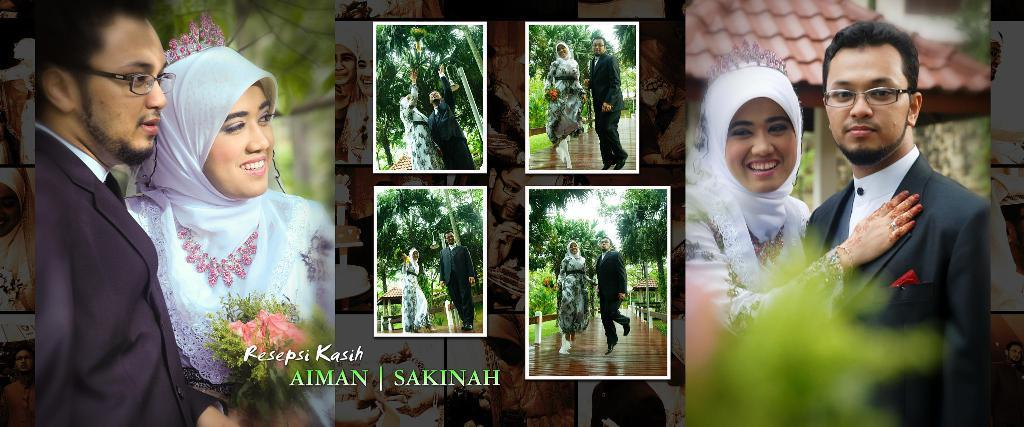Who are the people in the image? There is a man and a woman in the image. What are the genders of the individuals in the image? The man is male, and the woman is female. Can you describe the relationship between the man and the woman in the image? The facts provided do not give any information about the relationship between the man and the woman. What color is the wren perched on the man's shoulder in the image? There is no wren present in the image. 